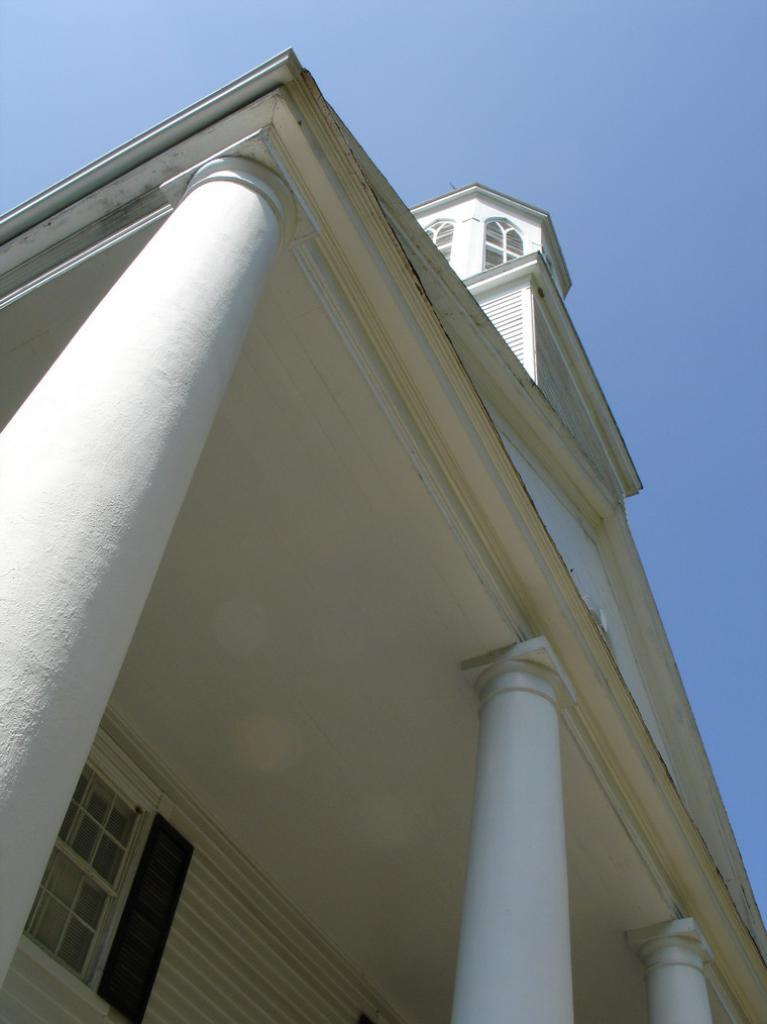What type of structure is present in the image? There is a building in the image. What architectural features can be seen on the building? The building has pillars and windows. What is the color of the building? The building is white in color. What is visible at the top of the image? The sky is visible at the top of the image. Can you tell me how many parents are standing next to the building in the image? There are no parents present in the image; it only features a building with pillars, windows, and a white color. Is there a bear visible on the roof of the building in the image? There is no bear present on the roof or anywhere else in the image; it only features a building with pillars, windows, and a white color. 